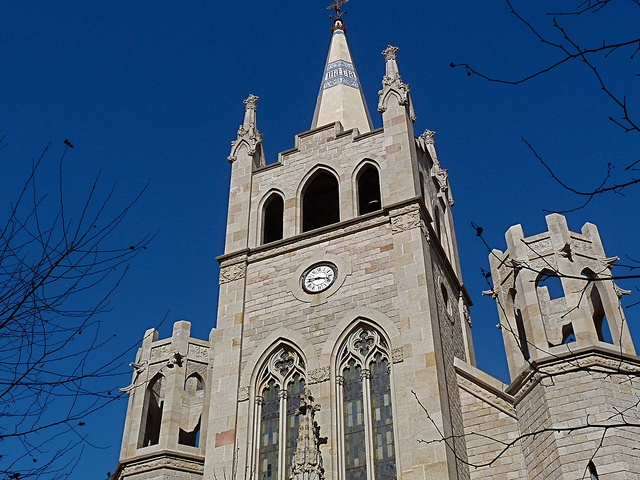Describe the objects in this image and their specific colors. I can see a clock in darkblue, white, darkgray, black, and gray tones in this image. 